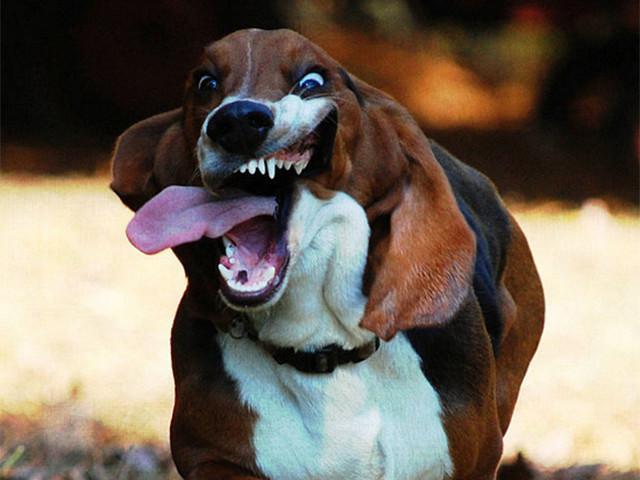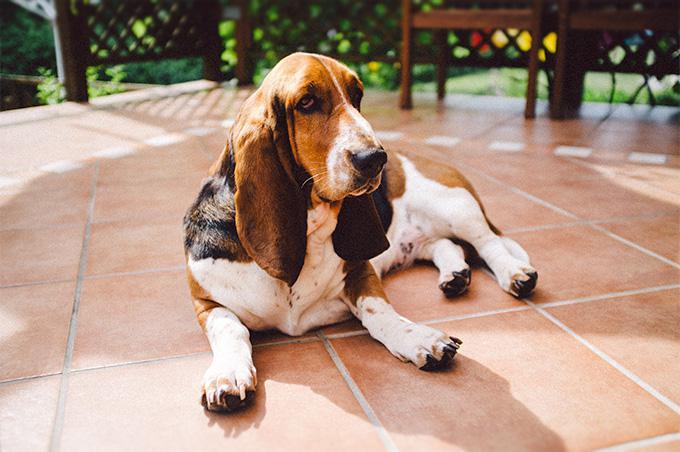The first image is the image on the left, the second image is the image on the right. Examine the images to the left and right. Is the description "One image shows a dog's body in profile, turned toward the left." accurate? Answer yes or no. No. 